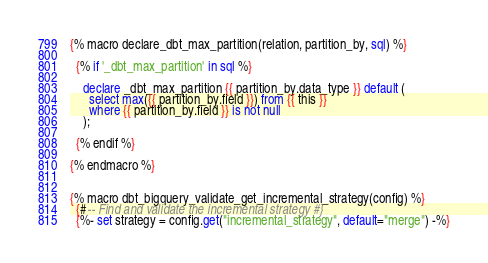<code> <loc_0><loc_0><loc_500><loc_500><_SQL_>{% macro declare_dbt_max_partition(relation, partition_by, sql) %}

  {% if '_dbt_max_partition' in sql %}

    declare _dbt_max_partition {{ partition_by.data_type }} default (
      select max({{ partition_by.field }}) from {{ this }}
      where {{ partition_by.field }} is not null
    );
  
  {% endif %}

{% endmacro %}


{% macro dbt_bigquery_validate_get_incremental_strategy(config) %}
  {#-- Find and validate the incremental strategy #}
  {%- set strategy = config.get("incremental_strategy", default="merge") -%}
</code> 